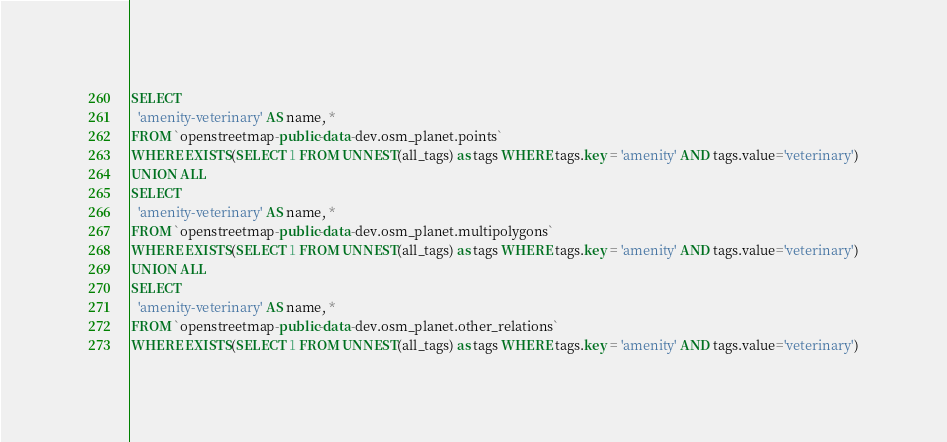<code> <loc_0><loc_0><loc_500><loc_500><_SQL_>SELECT
  'amenity-veterinary' AS name, *
FROM `openstreetmap-public-data-dev.osm_planet.points`
WHERE EXISTS(SELECT 1 FROM UNNEST(all_tags) as tags WHERE tags.key = 'amenity' AND tags.value='veterinary')
UNION ALL
SELECT
  'amenity-veterinary' AS name, *
FROM `openstreetmap-public-data-dev.osm_planet.multipolygons`
WHERE EXISTS(SELECT 1 FROM UNNEST(all_tags) as tags WHERE tags.key = 'amenity' AND tags.value='veterinary')
UNION ALL
SELECT
  'amenity-veterinary' AS name, *
FROM `openstreetmap-public-data-dev.osm_planet.other_relations`
WHERE EXISTS(SELECT 1 FROM UNNEST(all_tags) as tags WHERE tags.key = 'amenity' AND tags.value='veterinary')

</code> 